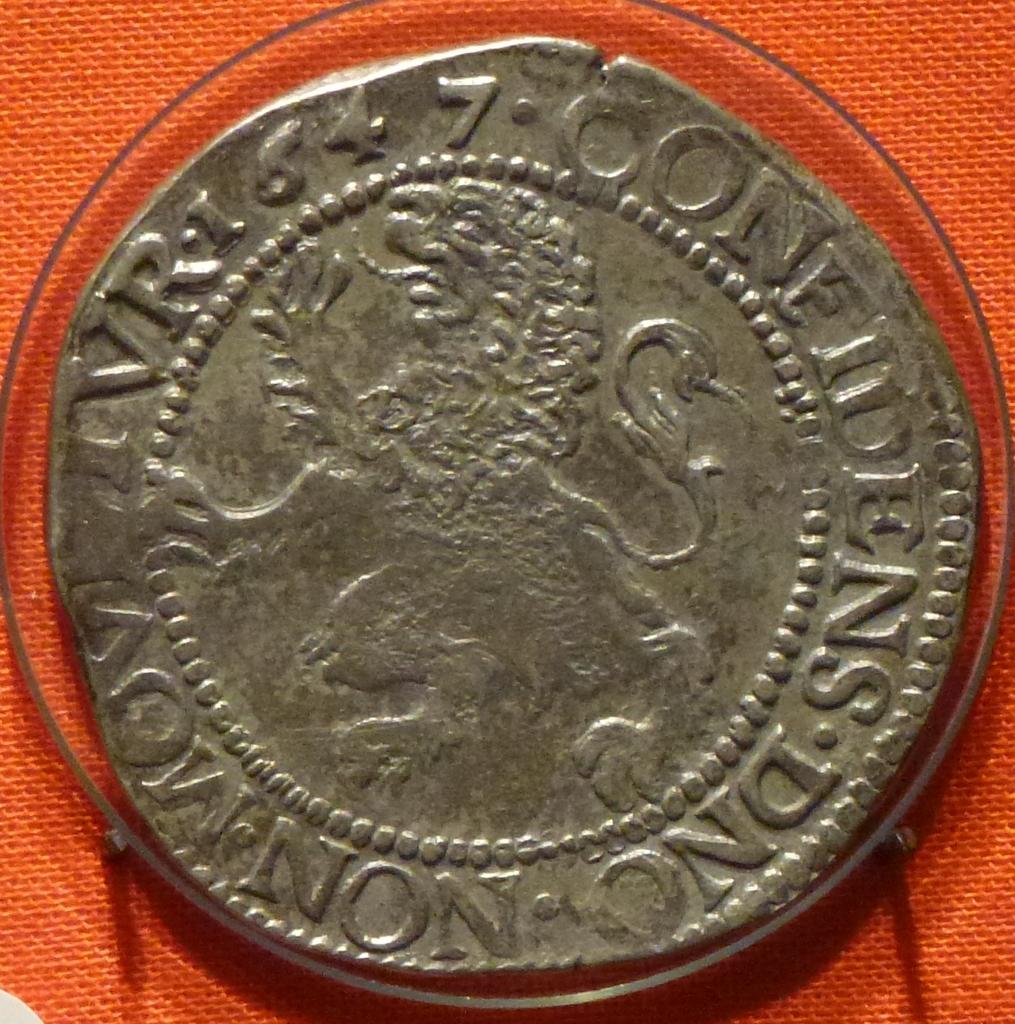What is the date on the coin?
Provide a succinct answer. 1647. Is the word "non" somewhere on this coin?
Your answer should be compact. Yes. 